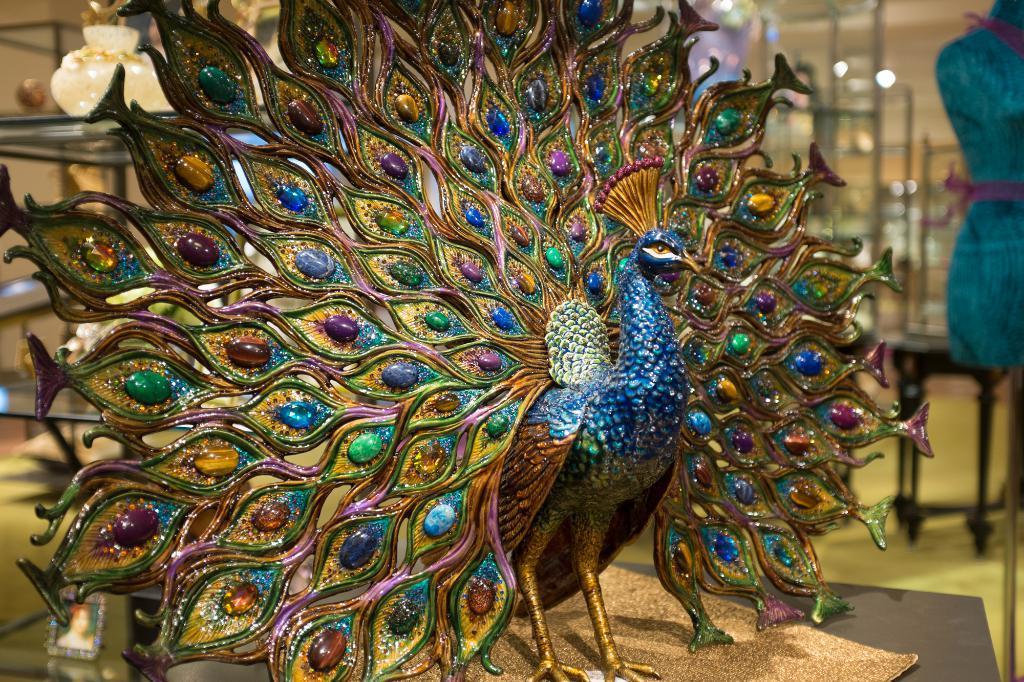In one or two sentences, can you explain what this image depicts? In this image we can see a statue. On the right side of the image we a mannequin and some poles. On the left side of the image we can see some objects placed on racks. In the bottom left corner of the image we can see a photo frame. 